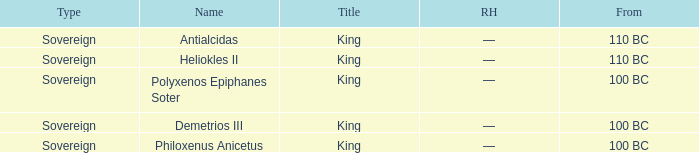When did Philoxenus Anicetus begin to hold power? 100 BC. 